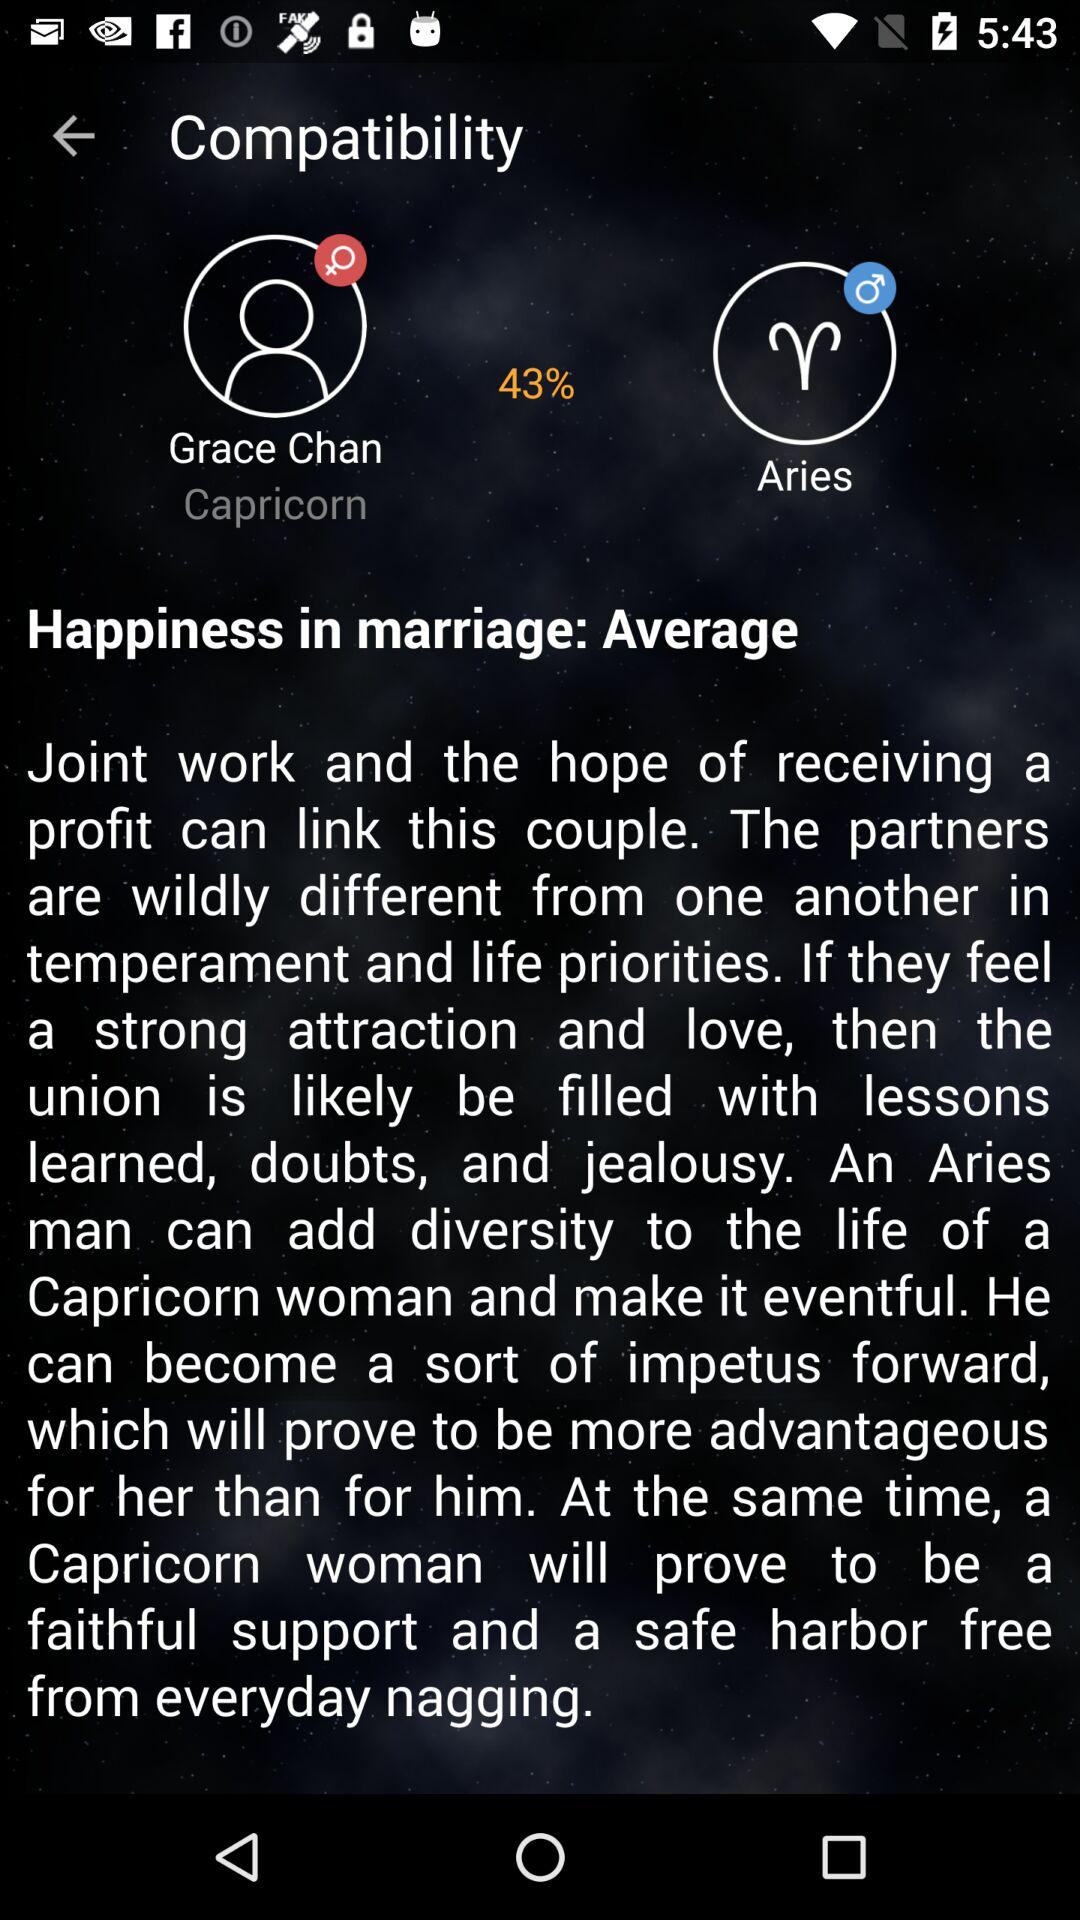What's the user name? The user name is Grace Chan. 